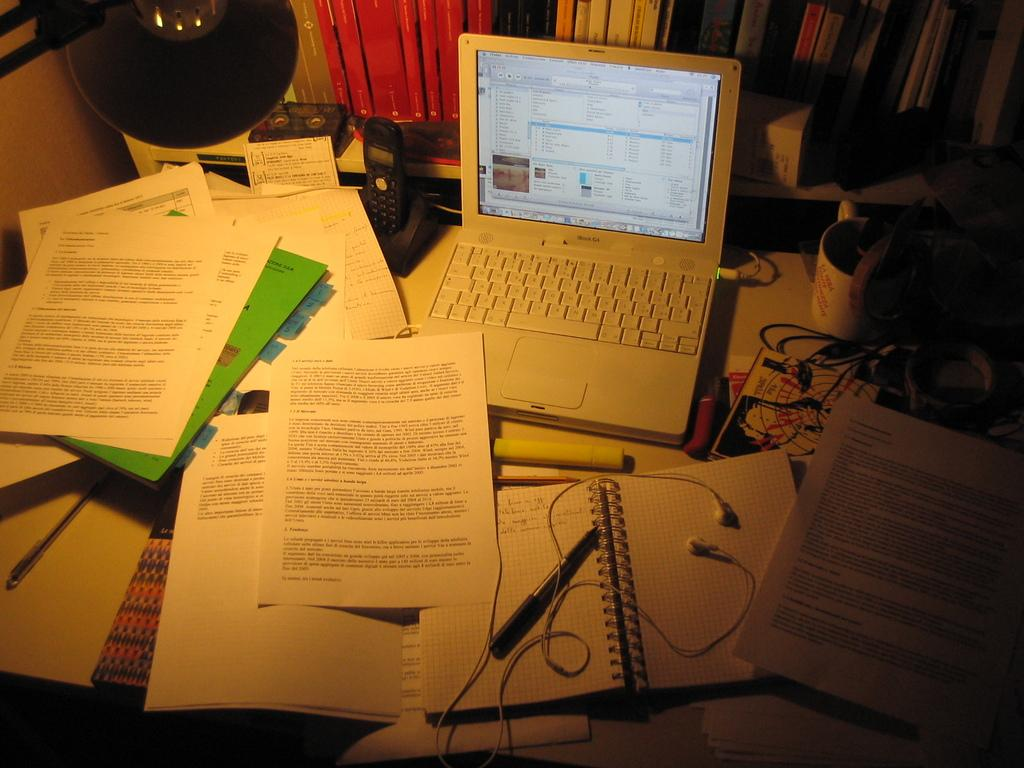What objects can be seen in the foreground area of the image? In the foreground area of the image, there are papers, wires, a laptop, and other items. Can you describe the laptop in the image? The laptop is located in the foreground area of the image. What type of objects can be seen in the background of the image? In the background of the image, there are books. Is there any lighting fixture visible in the image? There may be a lamp at the top side of the image. What type of love can be seen between the papers and the wires in the image? There is no indication of love between the papers and wires in the image; they are simply objects in the foreground area. Is there a battle taking place between the laptop and the other items in the image? No, there is no battle depicted in the image; the objects are simply arranged on a surface. 